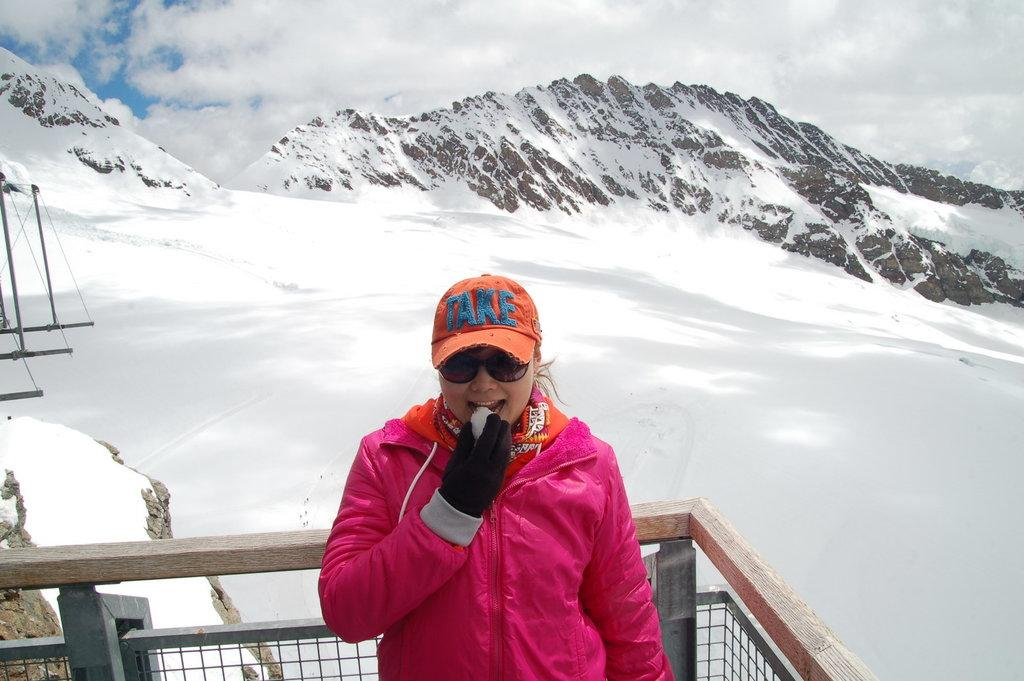What is the main subject of the image? There is a woman standing in the image. Where is the woman located in the image? The woman is standing at a fence. What can be seen in the background of the image? There is snow, a mountain, and sky visible in the background of the image. What is the condition of the sky in the image? The sky has clouds in it. What type of rifle is the woman holding in the image? There is no rifle present in the image; the woman is simply standing at a fence. What observation can be made about the woman's state of rest in the image? The image does not provide any information about the woman's state of rest, as she is standing at a fence. 